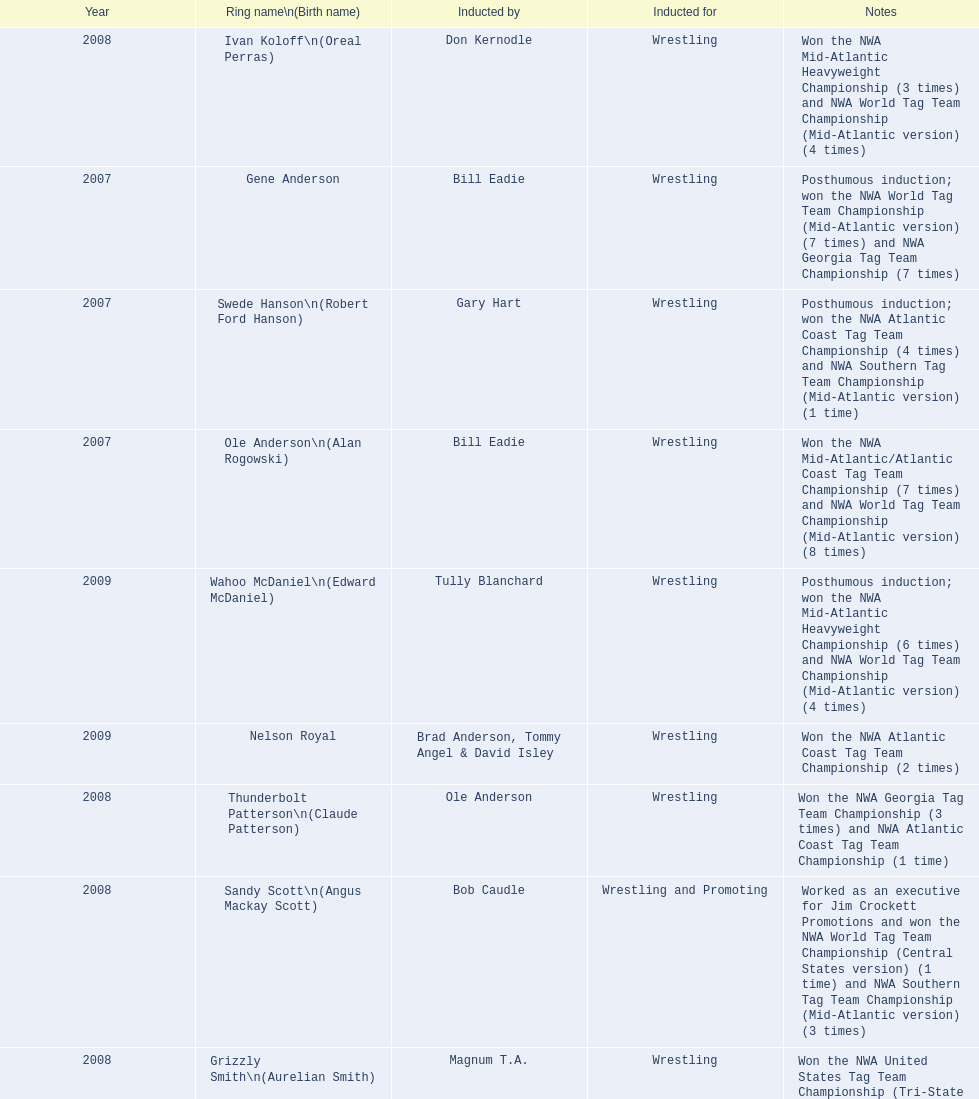Who was inducted after royal? Lance Russell. 